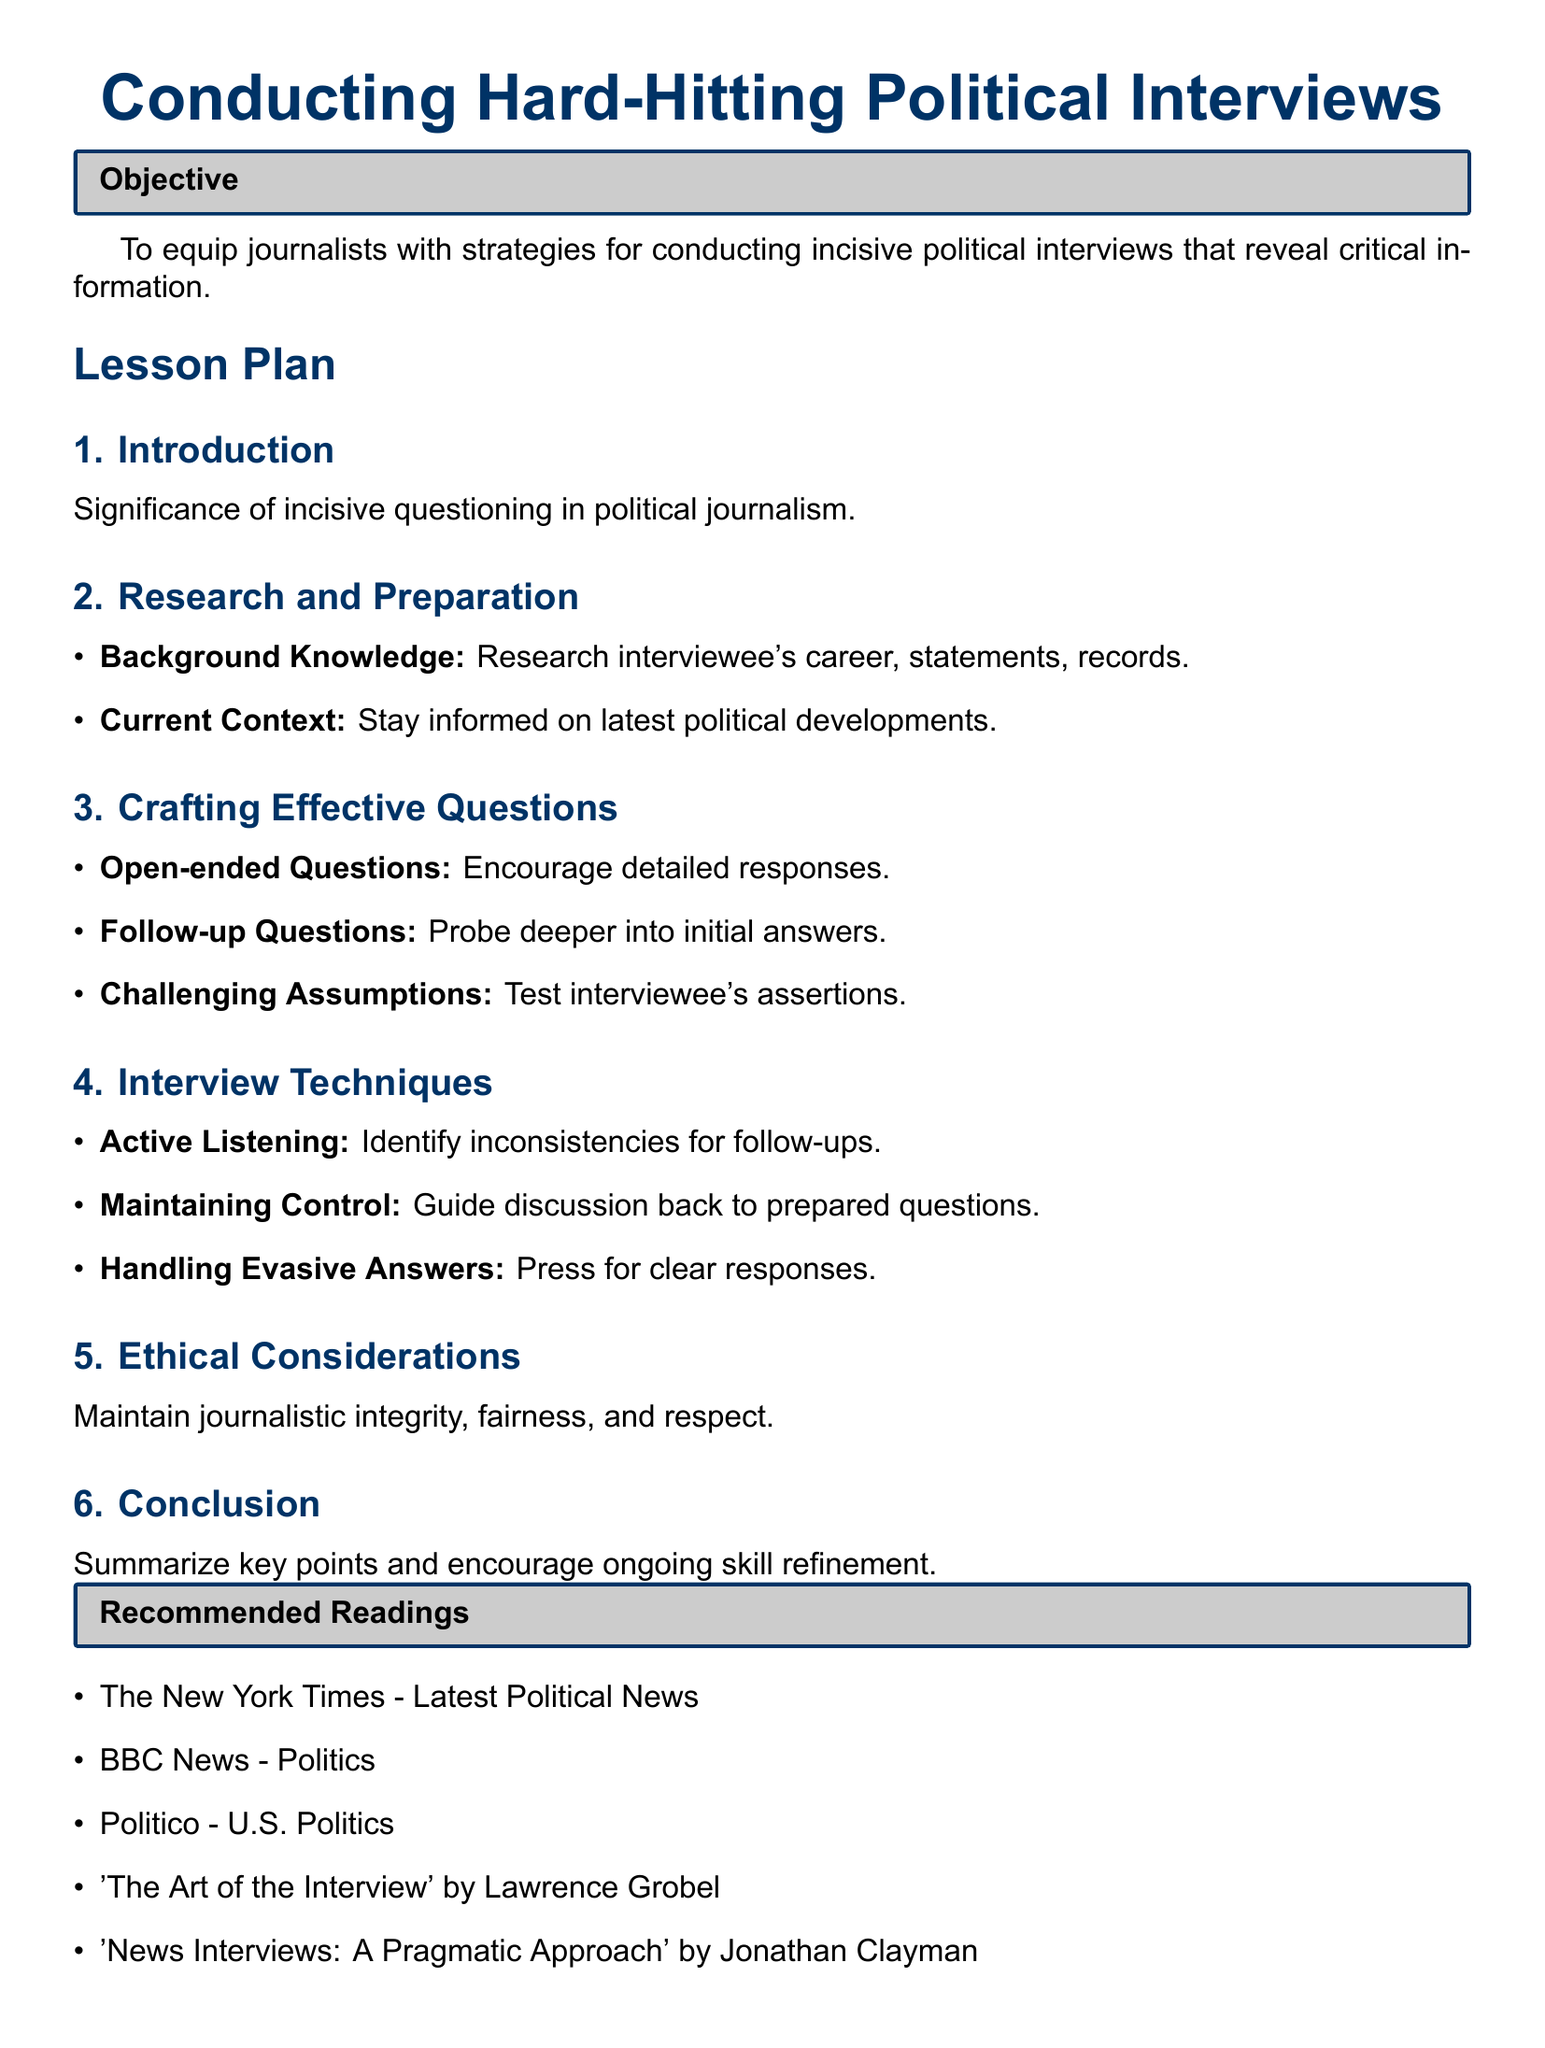What is the objective of the lesson plan? The objective is to equip journalists with strategies for conducting incisive political interviews that reveal critical information.
Answer: To equip journalists with strategies for conducting incisive political interviews that reveal critical information What is the first section of the lesson plan? The first section of the lesson plan is titled "Introduction."
Answer: Introduction What are open-ended questions used for? Open-ended questions are used to encourage detailed responses during interviews.
Answer: Encourage detailed responses What is one technique for handling evasive answers? One technique for handling evasive answers is to press for clear responses.
Answer: Press for clear responses What is recommended reading related to political news? One recommended reading is "The New York Times - Latest Political News."
Answer: The New York Times - Latest Political News 